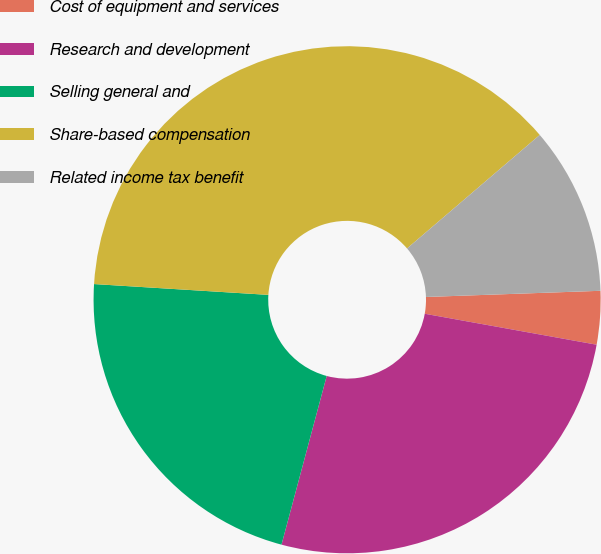Convert chart. <chart><loc_0><loc_0><loc_500><loc_500><pie_chart><fcel>Cost of equipment and services<fcel>Research and development<fcel>Selling general and<fcel>Share-based compensation<fcel>Related income tax benefit<nl><fcel>3.4%<fcel>26.33%<fcel>21.82%<fcel>37.75%<fcel>10.7%<nl></chart> 